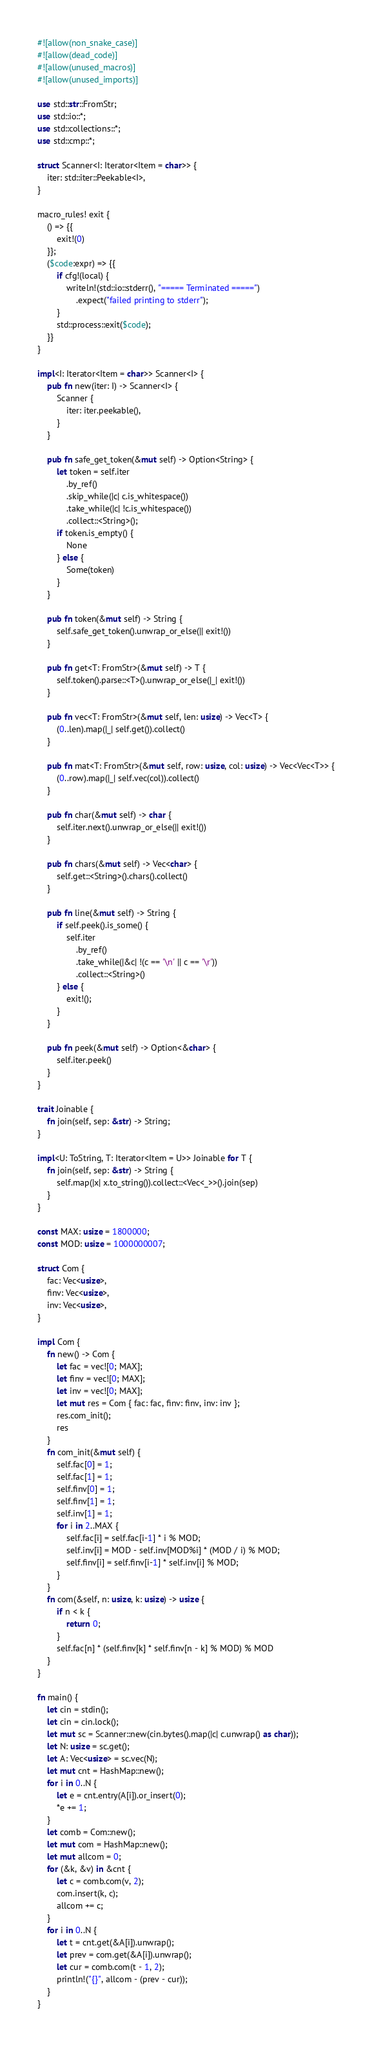Convert code to text. <code><loc_0><loc_0><loc_500><loc_500><_Rust_>#![allow(non_snake_case)]
#![allow(dead_code)]
#![allow(unused_macros)]
#![allow(unused_imports)]

use std::str::FromStr;
use std::io::*;
use std::collections::*;
use std::cmp::*;

struct Scanner<I: Iterator<Item = char>> {
    iter: std::iter::Peekable<I>,
}

macro_rules! exit {
    () => {{
        exit!(0)
    }};
    ($code:expr) => {{
        if cfg!(local) {
            writeln!(std::io::stderr(), "===== Terminated =====")
                .expect("failed printing to stderr");
        }
        std::process::exit($code);
    }}
}

impl<I: Iterator<Item = char>> Scanner<I> {
    pub fn new(iter: I) -> Scanner<I> {
        Scanner {
            iter: iter.peekable(),
        }
    }

    pub fn safe_get_token(&mut self) -> Option<String> {
        let token = self.iter
            .by_ref()
            .skip_while(|c| c.is_whitespace())
            .take_while(|c| !c.is_whitespace())
            .collect::<String>();
        if token.is_empty() {
            None
        } else {
            Some(token)
        }
    }

    pub fn token(&mut self) -> String {
        self.safe_get_token().unwrap_or_else(|| exit!())
    }

    pub fn get<T: FromStr>(&mut self) -> T {
        self.token().parse::<T>().unwrap_or_else(|_| exit!())
    }

    pub fn vec<T: FromStr>(&mut self, len: usize) -> Vec<T> {
        (0..len).map(|_| self.get()).collect()
    }

    pub fn mat<T: FromStr>(&mut self, row: usize, col: usize) -> Vec<Vec<T>> {
        (0..row).map(|_| self.vec(col)).collect()
    }

    pub fn char(&mut self) -> char {
        self.iter.next().unwrap_or_else(|| exit!())
    }

    pub fn chars(&mut self) -> Vec<char> {
        self.get::<String>().chars().collect()
    }

    pub fn line(&mut self) -> String {
        if self.peek().is_some() {
            self.iter
                .by_ref()
                .take_while(|&c| !(c == '\n' || c == '\r'))
                .collect::<String>()
        } else {
            exit!();
        }
    }

    pub fn peek(&mut self) -> Option<&char> {
        self.iter.peek()
    }
}

trait Joinable {
    fn join(self, sep: &str) -> String;
}

impl<U: ToString, T: Iterator<Item = U>> Joinable for T {
    fn join(self, sep: &str) -> String {
        self.map(|x| x.to_string()).collect::<Vec<_>>().join(sep)
    }
}

const MAX: usize = 1800000;
const MOD: usize = 1000000007;

struct Com {
    fac: Vec<usize>,
    finv: Vec<usize>,
    inv: Vec<usize>,
}

impl Com {
    fn new() -> Com {
        let fac = vec![0; MAX];
        let finv = vec![0; MAX];
        let inv = vec![0; MAX];
        let mut res = Com { fac: fac, finv: finv, inv: inv };
        res.com_init();
        res
    }
    fn com_init(&mut self) {
        self.fac[0] = 1;
        self.fac[1] = 1;
        self.finv[0] = 1;
        self.finv[1] = 1;
        self.inv[1] = 1;
        for i in 2..MAX {
            self.fac[i] = self.fac[i-1] * i % MOD;
            self.inv[i] = MOD - self.inv[MOD%i] * (MOD / i) % MOD;
            self.finv[i] = self.finv[i-1] * self.inv[i] % MOD;
        }
    }
    fn com(&self, n: usize, k: usize) -> usize {
        if n < k {
            return 0;
        }
        self.fac[n] * (self.finv[k] * self.finv[n - k] % MOD) % MOD
    }
}

fn main() {
    let cin = stdin();
    let cin = cin.lock();
    let mut sc = Scanner::new(cin.bytes().map(|c| c.unwrap() as char));
    let N: usize = sc.get();
    let A: Vec<usize> = sc.vec(N);
    let mut cnt = HashMap::new();
    for i in 0..N {
        let e = cnt.entry(A[i]).or_insert(0);
        *e += 1;
    }
    let comb = Com::new();
    let mut com = HashMap::new();
    let mut allcom = 0;
    for (&k, &v) in &cnt {
        let c = comb.com(v, 2);
        com.insert(k, c);
        allcom += c;
    }
    for i in 0..N {
        let t = cnt.get(&A[i]).unwrap();
        let prev = com.get(&A[i]).unwrap();
        let cur = comb.com(t - 1, 2);
        println!("{}", allcom - (prev - cur));
    }
}
</code> 